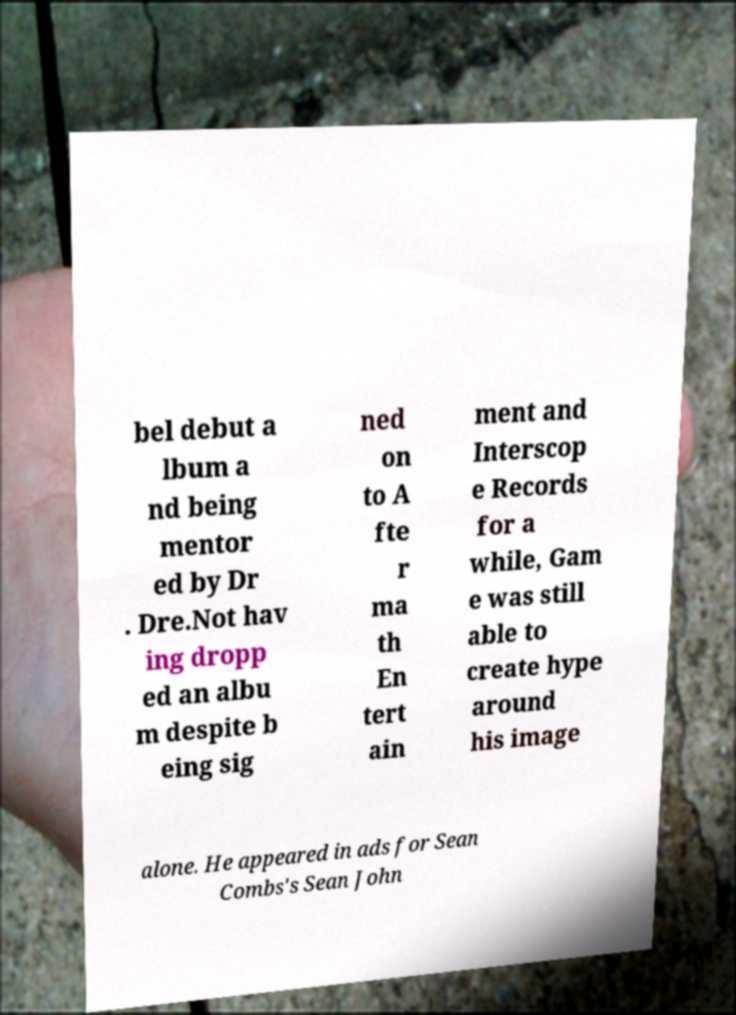I need the written content from this picture converted into text. Can you do that? bel debut a lbum a nd being mentor ed by Dr . Dre.Not hav ing dropp ed an albu m despite b eing sig ned on to A fte r ma th En tert ain ment and Interscop e Records for a while, Gam e was still able to create hype around his image alone. He appeared in ads for Sean Combs's Sean John 